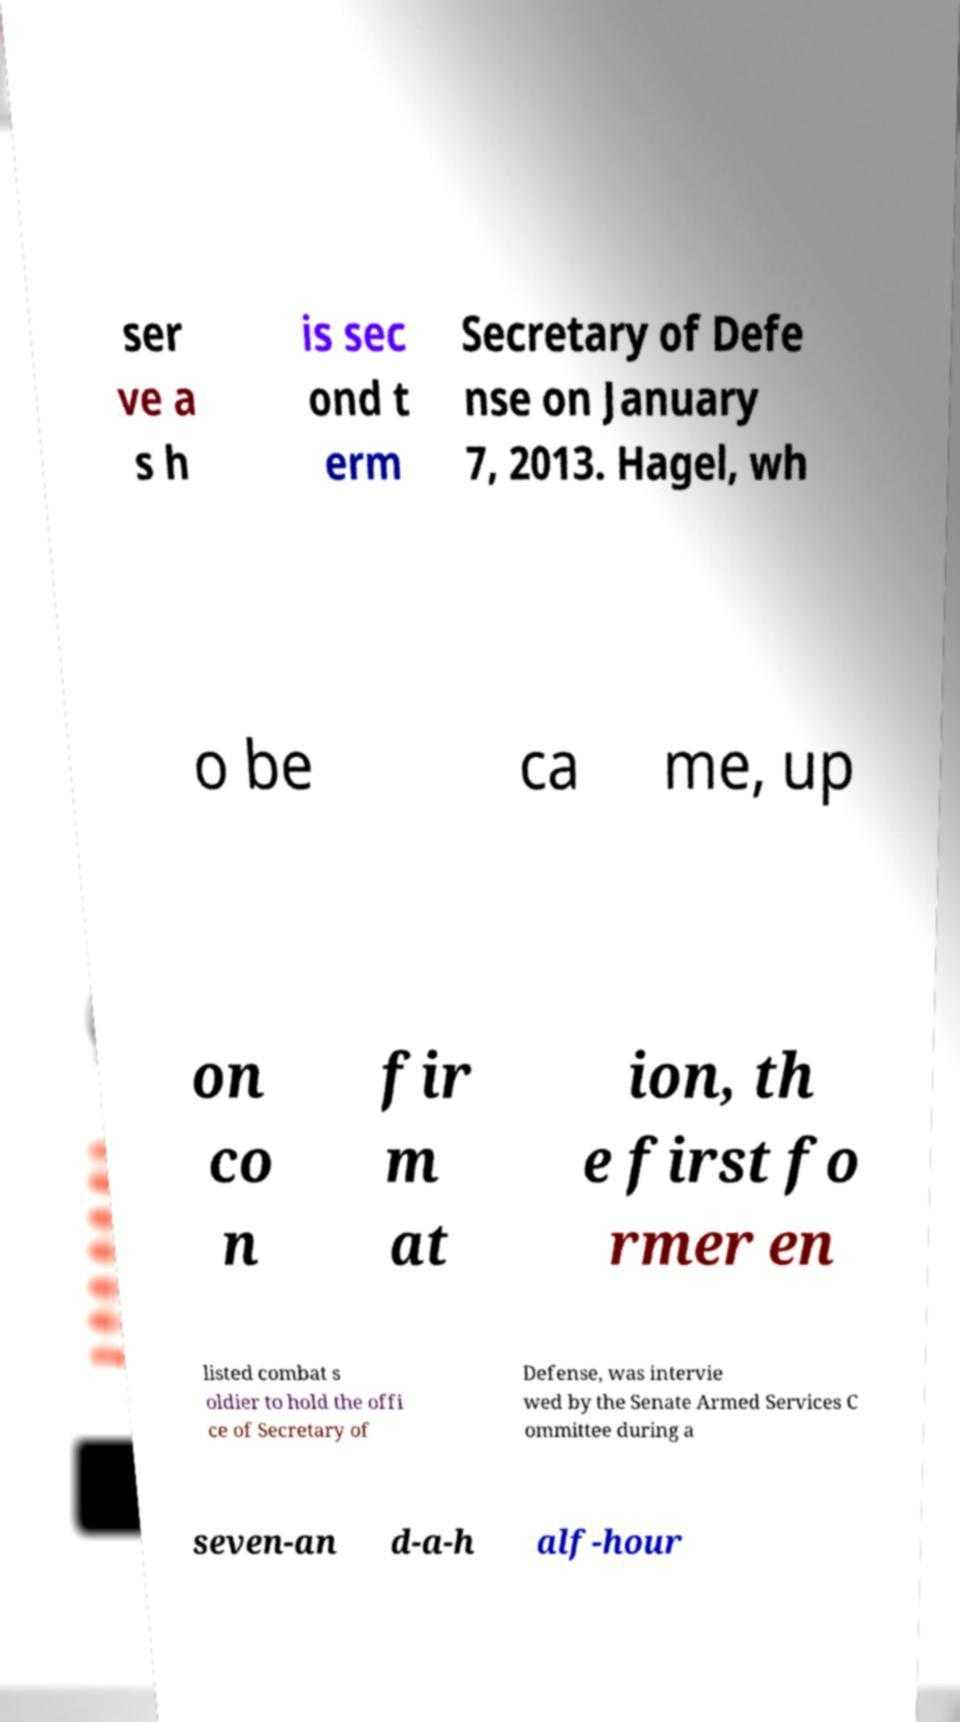Could you assist in decoding the text presented in this image and type it out clearly? ser ve a s h is sec ond t erm Secretary of Defe nse on January 7, 2013. Hagel, wh o be ca me, up on co n fir m at ion, th e first fo rmer en listed combat s oldier to hold the offi ce of Secretary of Defense, was intervie wed by the Senate Armed Services C ommittee during a seven-an d-a-h alf-hour 